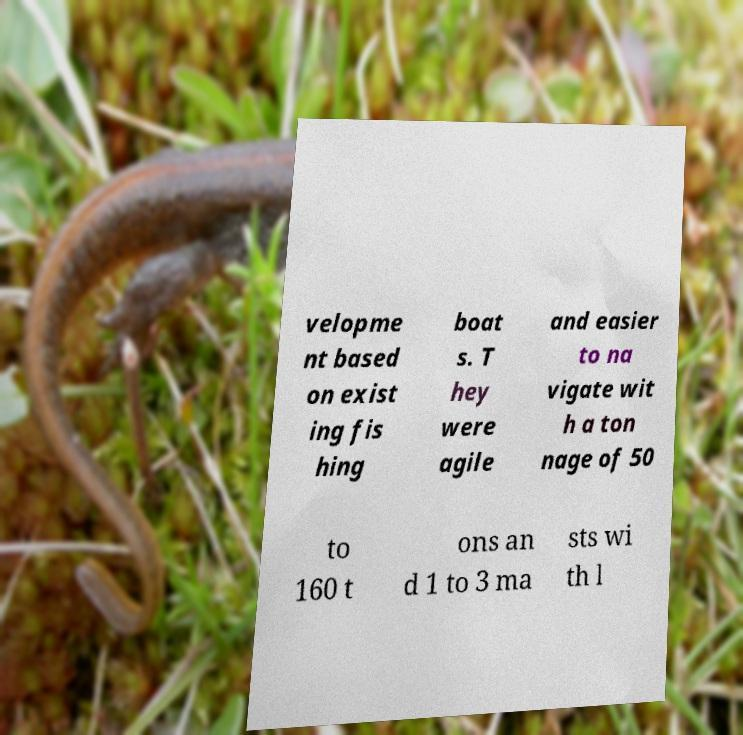What messages or text are displayed in this image? I need them in a readable, typed format. velopme nt based on exist ing fis hing boat s. T hey were agile and easier to na vigate wit h a ton nage of 50 to 160 t ons an d 1 to 3 ma sts wi th l 